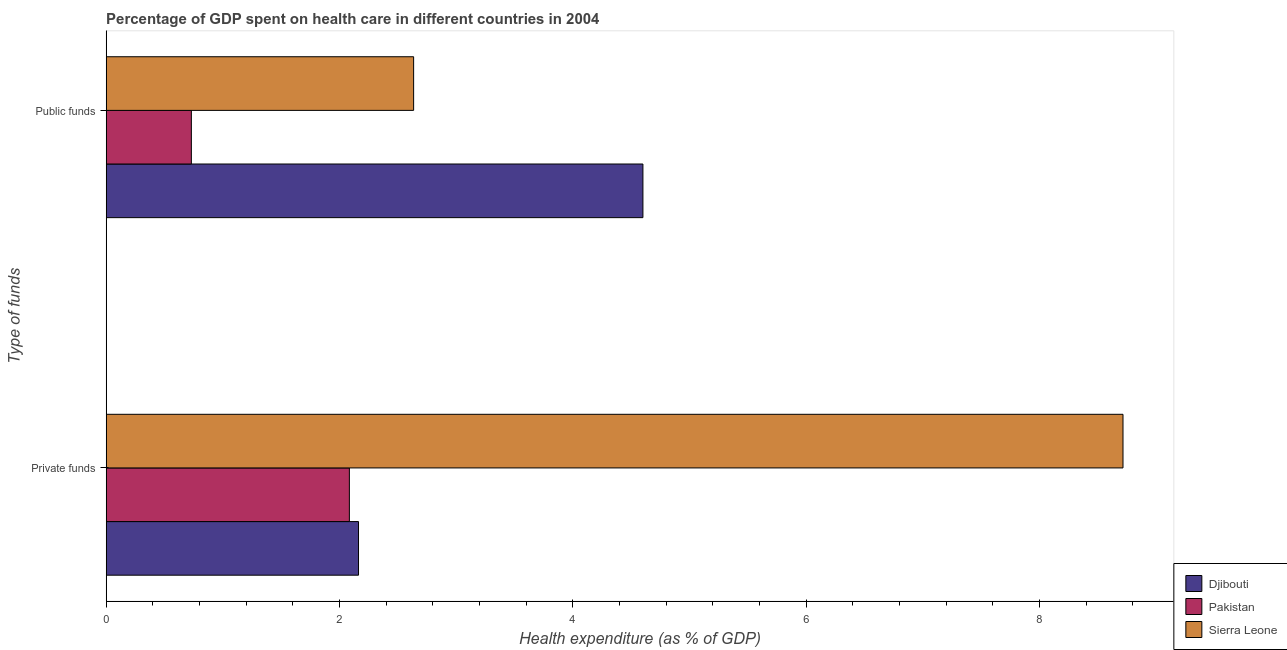How many different coloured bars are there?
Your answer should be very brief. 3. How many groups of bars are there?
Offer a very short reply. 2. Are the number of bars per tick equal to the number of legend labels?
Provide a succinct answer. Yes. How many bars are there on the 1st tick from the top?
Provide a short and direct response. 3. How many bars are there on the 1st tick from the bottom?
Your answer should be compact. 3. What is the label of the 2nd group of bars from the top?
Your answer should be very brief. Private funds. What is the amount of public funds spent in healthcare in Pakistan?
Offer a terse response. 0.73. Across all countries, what is the maximum amount of private funds spent in healthcare?
Make the answer very short. 8.72. Across all countries, what is the minimum amount of public funds spent in healthcare?
Give a very brief answer. 0.73. In which country was the amount of public funds spent in healthcare maximum?
Provide a short and direct response. Djibouti. In which country was the amount of public funds spent in healthcare minimum?
Make the answer very short. Pakistan. What is the total amount of public funds spent in healthcare in the graph?
Provide a succinct answer. 7.97. What is the difference between the amount of public funds spent in healthcare in Djibouti and that in Sierra Leone?
Your response must be concise. 1.97. What is the difference between the amount of public funds spent in healthcare in Sierra Leone and the amount of private funds spent in healthcare in Pakistan?
Give a very brief answer. 0.55. What is the average amount of public funds spent in healthcare per country?
Provide a succinct answer. 2.66. What is the difference between the amount of private funds spent in healthcare and amount of public funds spent in healthcare in Djibouti?
Provide a short and direct response. -2.44. What is the ratio of the amount of public funds spent in healthcare in Sierra Leone to that in Pakistan?
Keep it short and to the point. 3.61. Is the amount of private funds spent in healthcare in Pakistan less than that in Djibouti?
Offer a terse response. Yes. What does the 2nd bar from the top in Public funds represents?
Your answer should be very brief. Pakistan. Are all the bars in the graph horizontal?
Your answer should be compact. Yes. How many countries are there in the graph?
Your answer should be compact. 3. What is the difference between two consecutive major ticks on the X-axis?
Provide a succinct answer. 2. Does the graph contain grids?
Give a very brief answer. No. Where does the legend appear in the graph?
Provide a short and direct response. Bottom right. How many legend labels are there?
Provide a succinct answer. 3. What is the title of the graph?
Your answer should be compact. Percentage of GDP spent on health care in different countries in 2004. What is the label or title of the X-axis?
Your answer should be very brief. Health expenditure (as % of GDP). What is the label or title of the Y-axis?
Offer a very short reply. Type of funds. What is the Health expenditure (as % of GDP) of Djibouti in Private funds?
Your answer should be compact. 2.16. What is the Health expenditure (as % of GDP) of Pakistan in Private funds?
Your answer should be compact. 2.08. What is the Health expenditure (as % of GDP) of Sierra Leone in Private funds?
Ensure brevity in your answer.  8.72. What is the Health expenditure (as % of GDP) of Djibouti in Public funds?
Keep it short and to the point. 4.6. What is the Health expenditure (as % of GDP) of Pakistan in Public funds?
Provide a succinct answer. 0.73. What is the Health expenditure (as % of GDP) in Sierra Leone in Public funds?
Your response must be concise. 2.64. Across all Type of funds, what is the maximum Health expenditure (as % of GDP) of Djibouti?
Ensure brevity in your answer.  4.6. Across all Type of funds, what is the maximum Health expenditure (as % of GDP) in Pakistan?
Make the answer very short. 2.08. Across all Type of funds, what is the maximum Health expenditure (as % of GDP) of Sierra Leone?
Your response must be concise. 8.72. Across all Type of funds, what is the minimum Health expenditure (as % of GDP) of Djibouti?
Ensure brevity in your answer.  2.16. Across all Type of funds, what is the minimum Health expenditure (as % of GDP) in Pakistan?
Ensure brevity in your answer.  0.73. Across all Type of funds, what is the minimum Health expenditure (as % of GDP) in Sierra Leone?
Keep it short and to the point. 2.64. What is the total Health expenditure (as % of GDP) in Djibouti in the graph?
Your response must be concise. 6.76. What is the total Health expenditure (as % of GDP) of Pakistan in the graph?
Provide a short and direct response. 2.81. What is the total Health expenditure (as % of GDP) in Sierra Leone in the graph?
Give a very brief answer. 11.35. What is the difference between the Health expenditure (as % of GDP) of Djibouti in Private funds and that in Public funds?
Keep it short and to the point. -2.44. What is the difference between the Health expenditure (as % of GDP) of Pakistan in Private funds and that in Public funds?
Your response must be concise. 1.35. What is the difference between the Health expenditure (as % of GDP) in Sierra Leone in Private funds and that in Public funds?
Offer a very short reply. 6.08. What is the difference between the Health expenditure (as % of GDP) in Djibouti in Private funds and the Health expenditure (as % of GDP) in Pakistan in Public funds?
Provide a short and direct response. 1.43. What is the difference between the Health expenditure (as % of GDP) of Djibouti in Private funds and the Health expenditure (as % of GDP) of Sierra Leone in Public funds?
Provide a succinct answer. -0.47. What is the difference between the Health expenditure (as % of GDP) of Pakistan in Private funds and the Health expenditure (as % of GDP) of Sierra Leone in Public funds?
Keep it short and to the point. -0.55. What is the average Health expenditure (as % of GDP) in Djibouti per Type of funds?
Keep it short and to the point. 3.38. What is the average Health expenditure (as % of GDP) in Pakistan per Type of funds?
Your answer should be compact. 1.41. What is the average Health expenditure (as % of GDP) of Sierra Leone per Type of funds?
Make the answer very short. 5.68. What is the difference between the Health expenditure (as % of GDP) of Djibouti and Health expenditure (as % of GDP) of Pakistan in Private funds?
Provide a short and direct response. 0.08. What is the difference between the Health expenditure (as % of GDP) of Djibouti and Health expenditure (as % of GDP) of Sierra Leone in Private funds?
Provide a succinct answer. -6.55. What is the difference between the Health expenditure (as % of GDP) of Pakistan and Health expenditure (as % of GDP) of Sierra Leone in Private funds?
Offer a very short reply. -6.63. What is the difference between the Health expenditure (as % of GDP) in Djibouti and Health expenditure (as % of GDP) in Pakistan in Public funds?
Provide a short and direct response. 3.87. What is the difference between the Health expenditure (as % of GDP) in Djibouti and Health expenditure (as % of GDP) in Sierra Leone in Public funds?
Provide a short and direct response. 1.97. What is the difference between the Health expenditure (as % of GDP) of Pakistan and Health expenditure (as % of GDP) of Sierra Leone in Public funds?
Offer a terse response. -1.91. What is the ratio of the Health expenditure (as % of GDP) of Djibouti in Private funds to that in Public funds?
Give a very brief answer. 0.47. What is the ratio of the Health expenditure (as % of GDP) in Pakistan in Private funds to that in Public funds?
Offer a terse response. 2.86. What is the ratio of the Health expenditure (as % of GDP) of Sierra Leone in Private funds to that in Public funds?
Your answer should be compact. 3.31. What is the difference between the highest and the second highest Health expenditure (as % of GDP) of Djibouti?
Provide a succinct answer. 2.44. What is the difference between the highest and the second highest Health expenditure (as % of GDP) of Pakistan?
Keep it short and to the point. 1.35. What is the difference between the highest and the second highest Health expenditure (as % of GDP) of Sierra Leone?
Make the answer very short. 6.08. What is the difference between the highest and the lowest Health expenditure (as % of GDP) of Djibouti?
Your answer should be very brief. 2.44. What is the difference between the highest and the lowest Health expenditure (as % of GDP) in Pakistan?
Make the answer very short. 1.35. What is the difference between the highest and the lowest Health expenditure (as % of GDP) in Sierra Leone?
Offer a terse response. 6.08. 